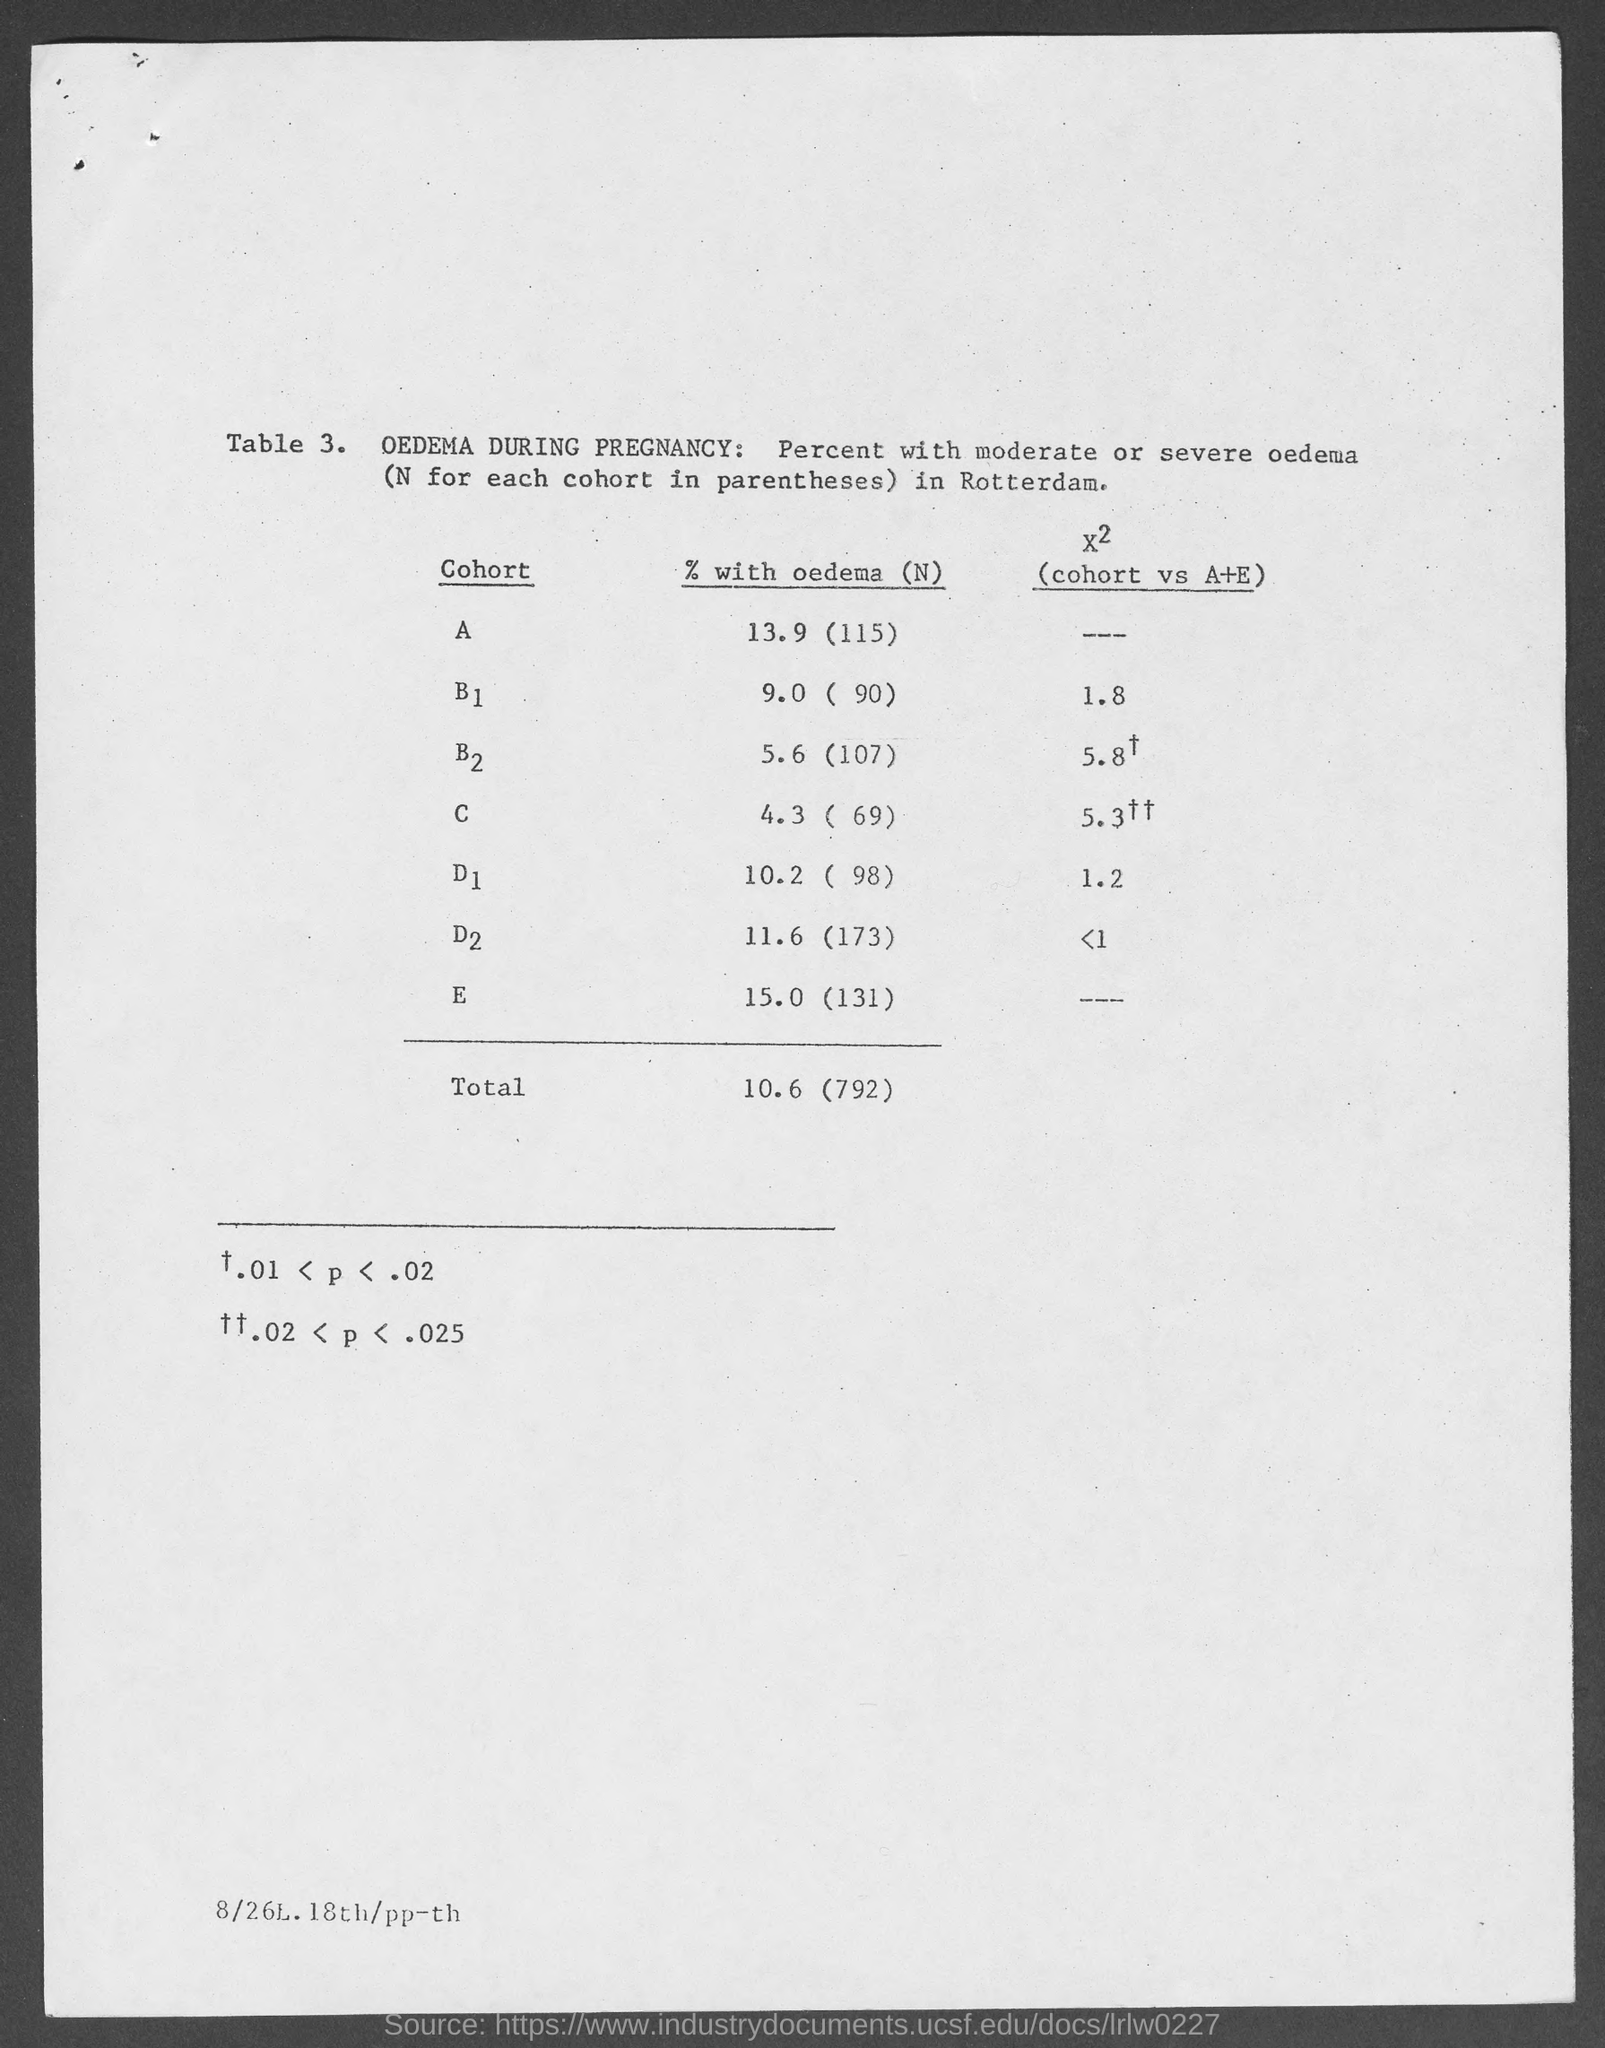Outline some significant characteristics in this image. The total value of % with oedema (N) is 10.6 (792). The percentage of participants with oedema (N=115) in cohort A is 13.9. 